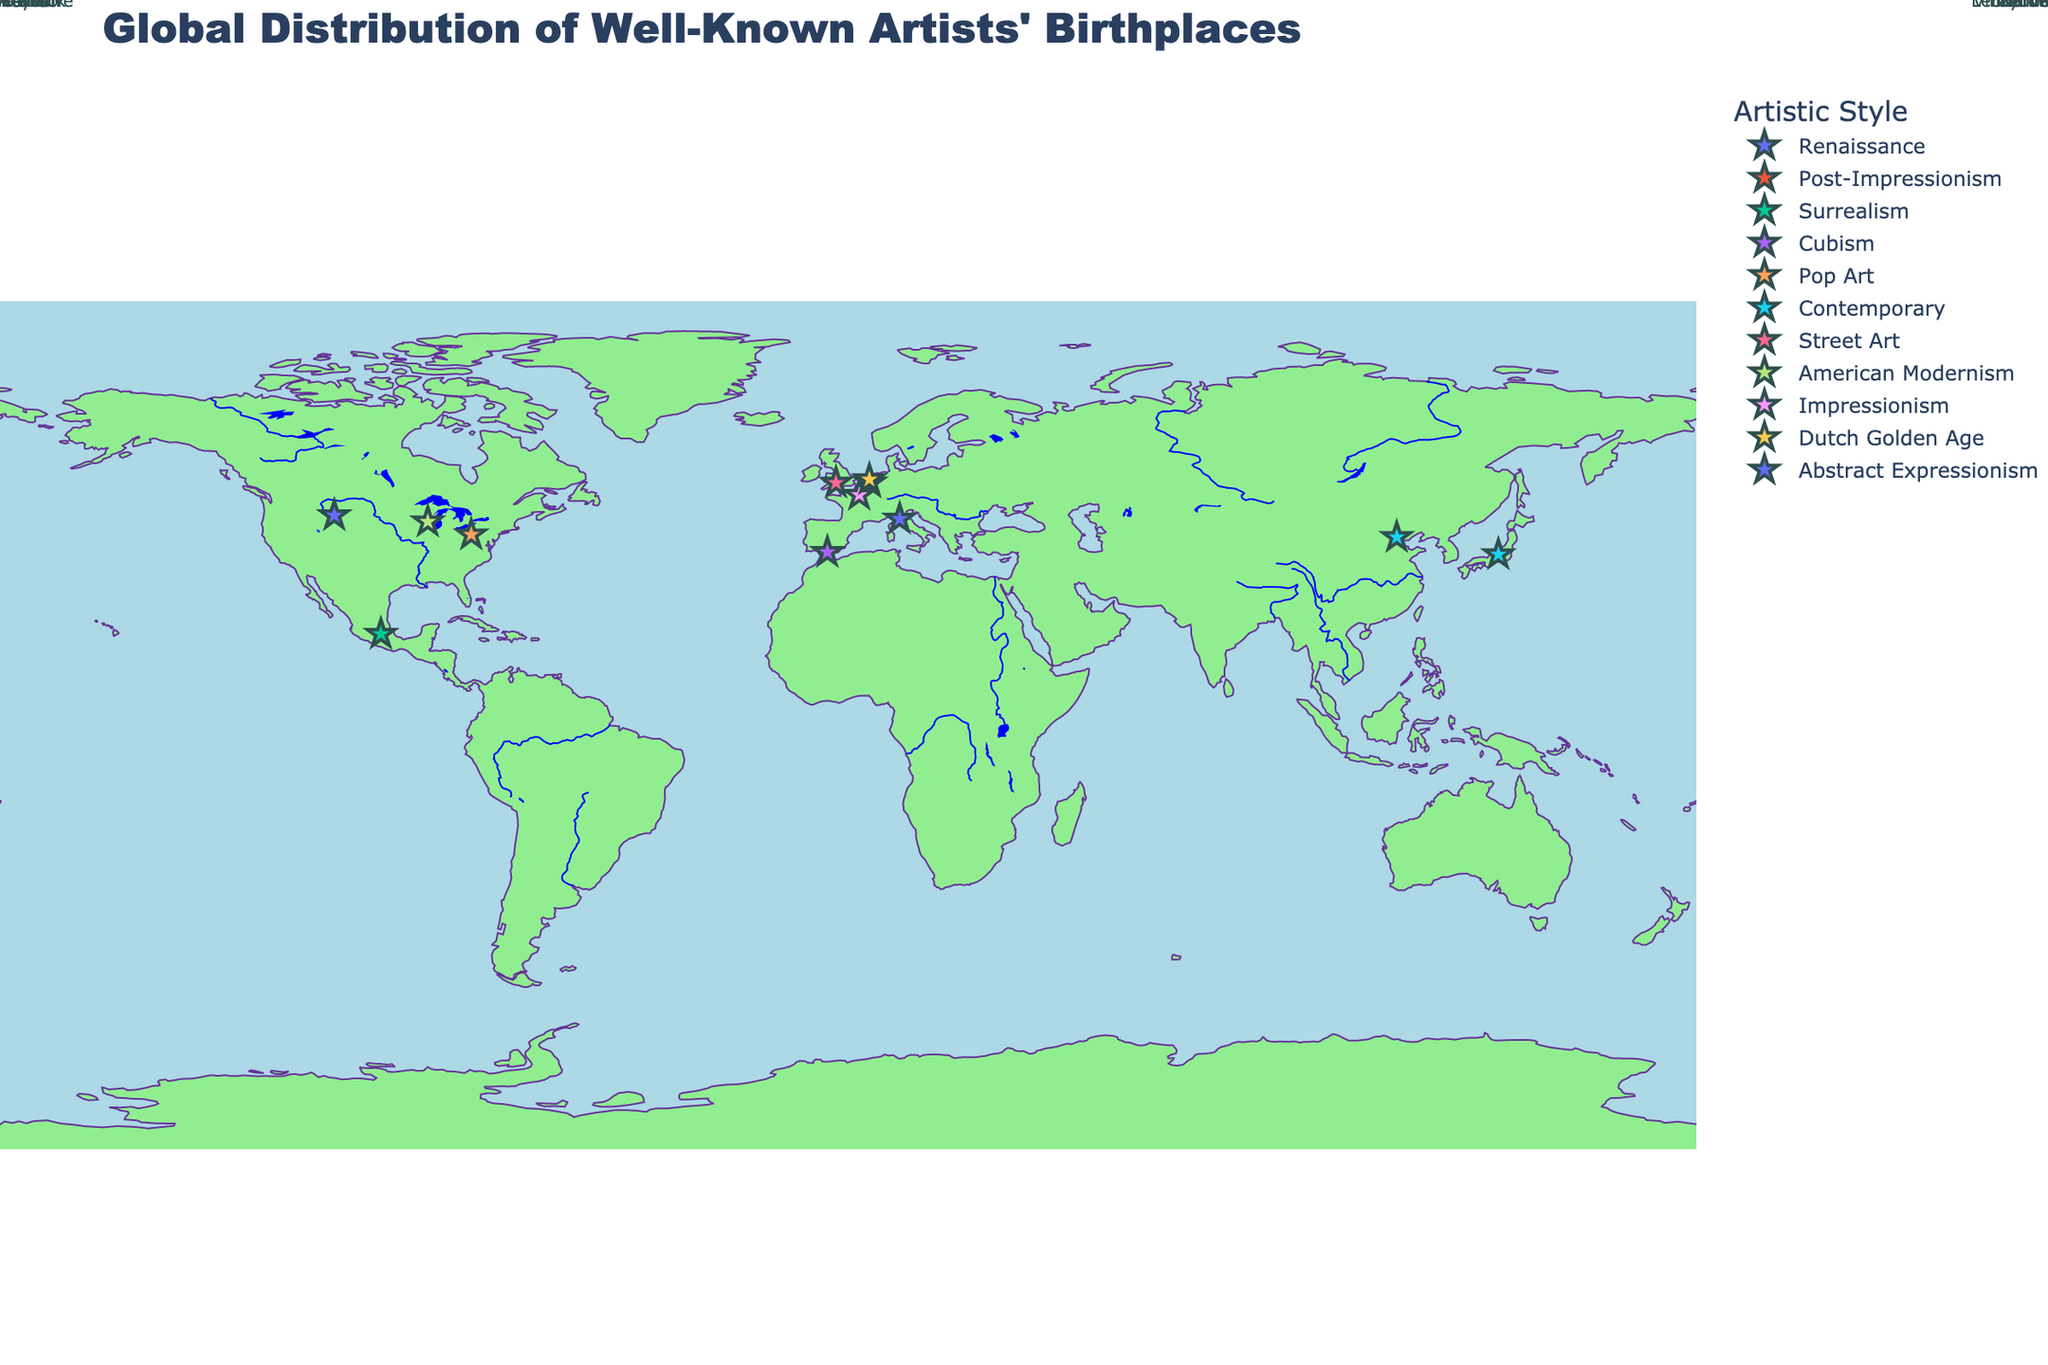What is the title of the figure? The title is usually found at the top of the figure, and in this plot, it specifies what the map is about.
Answer: Global Distribution of Well-Known Artists' Birthplaces How many artists are shown on the map? By counting the markers representing data points for each artist on the map, we find the total number of artists.
Answer: 12 Which artist was born closest to the equator? The equator is at latitude 0°. By looking at the latitude closest to 0°, we identify Frida Kahlo as the artist whose birthplace in Coyoacán (19.3437) is closest to the equator.
Answer: Frida Kahlo Which artistic style has the most birthplaces on the map? By identifying the number of markers for each artistic style, we determine which one has the most instances. By examining the plot and counting the occurrences, ‘Contemporary’ appears twice, while all other styles appear only once.
Answer: Contemporary What is the range of latitudes in this data set? To determine the latitude range, identify the northernmost and southernmost points (52.1601 and 19.3437), then calculate the difference: 52.1601 - 19.3437 = 32.8164.
Answer: 32.8164 Which two artists were born closest to each other in terms of latitude? Looking at the latitude values, compare and find the smallest difference between them. Leonardo da Vinci (43.7844) and Georgia O'Keeffe (43.1836) are the closest, with a difference of 0.6008.
Answer: Leonardo da Vinci and Georgia O'Keeffe What is the average longitude of the European artists' birthplaces? Identify the longitudes of artists born in Europe (Leonardo da Vinci, Vincent van Gogh, Pablo Picasso, Claude Monet, Rembrandt). Calculate the average: (10.9264 + 4.6592 - 4.4214 + 2.3522 + 4.4970) / 5 = 3.60268.
Answer: 3.60 Which birthplaces are marked in the continent of North America? By identifying the markers located in North America, note the birthplaces and corresponding artists. These are Pittsburgh (Andy Warhol), Sun Prairie (Georgia O'Keeffe), and Cody (Jackson Pollock).
Answer: Pittsburgh, Sun Prairie, Cody 